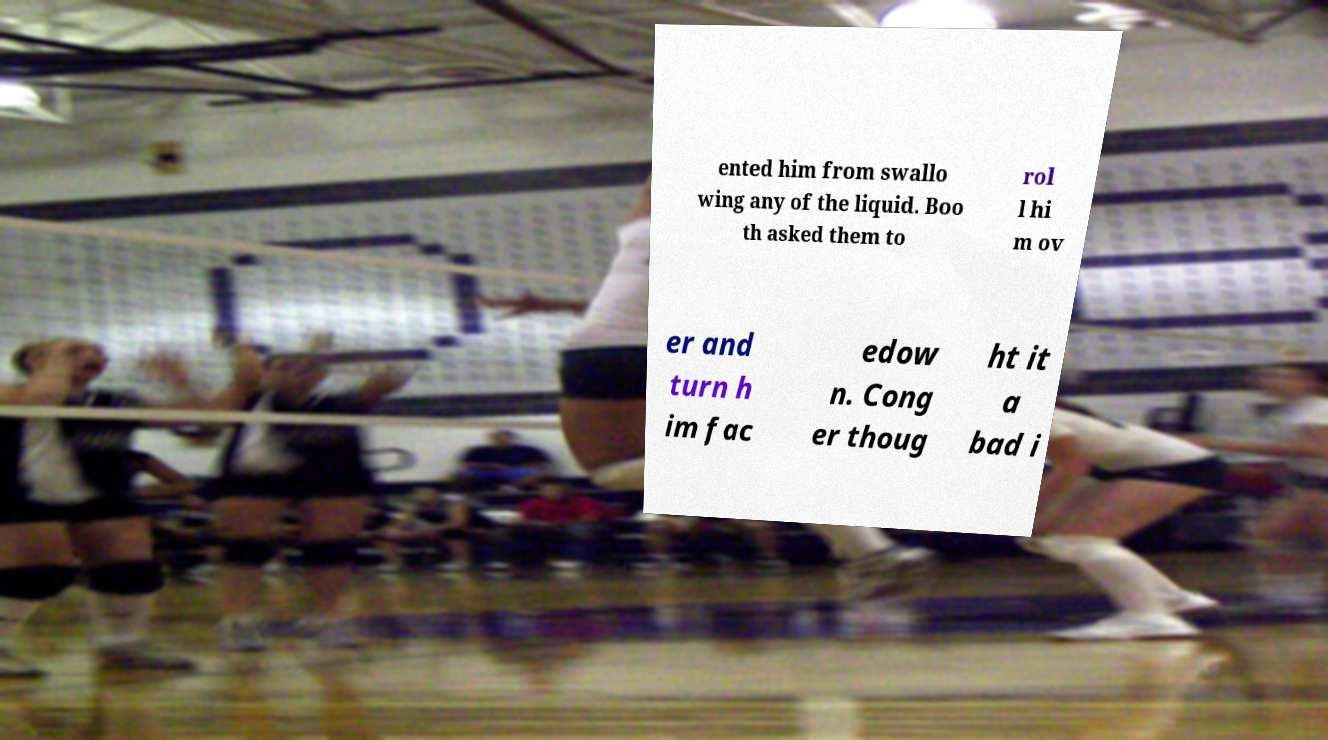Could you assist in decoding the text presented in this image and type it out clearly? ented him from swallo wing any of the liquid. Boo th asked them to rol l hi m ov er and turn h im fac edow n. Cong er thoug ht it a bad i 